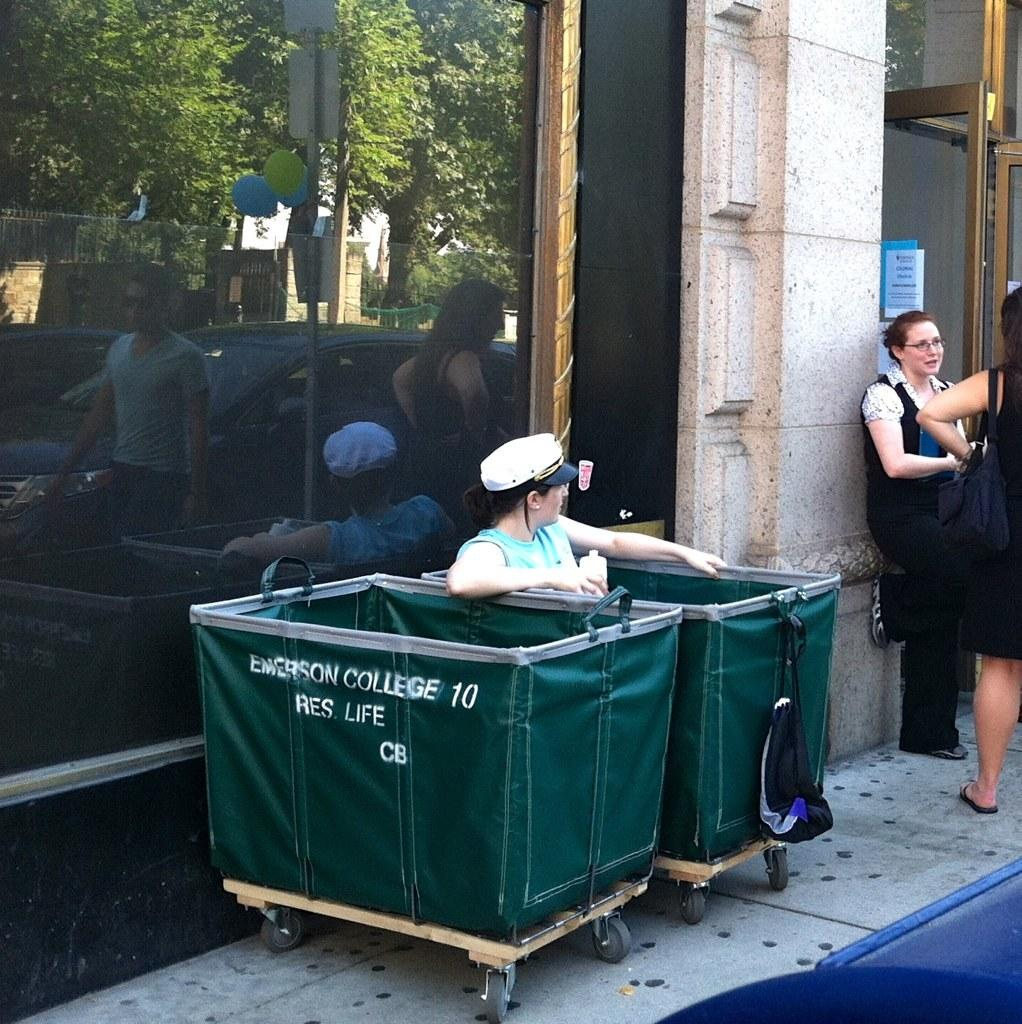<image>
Present a compact description of the photo's key features. A person sits in a green container that is one of two owned by Emerson College. 